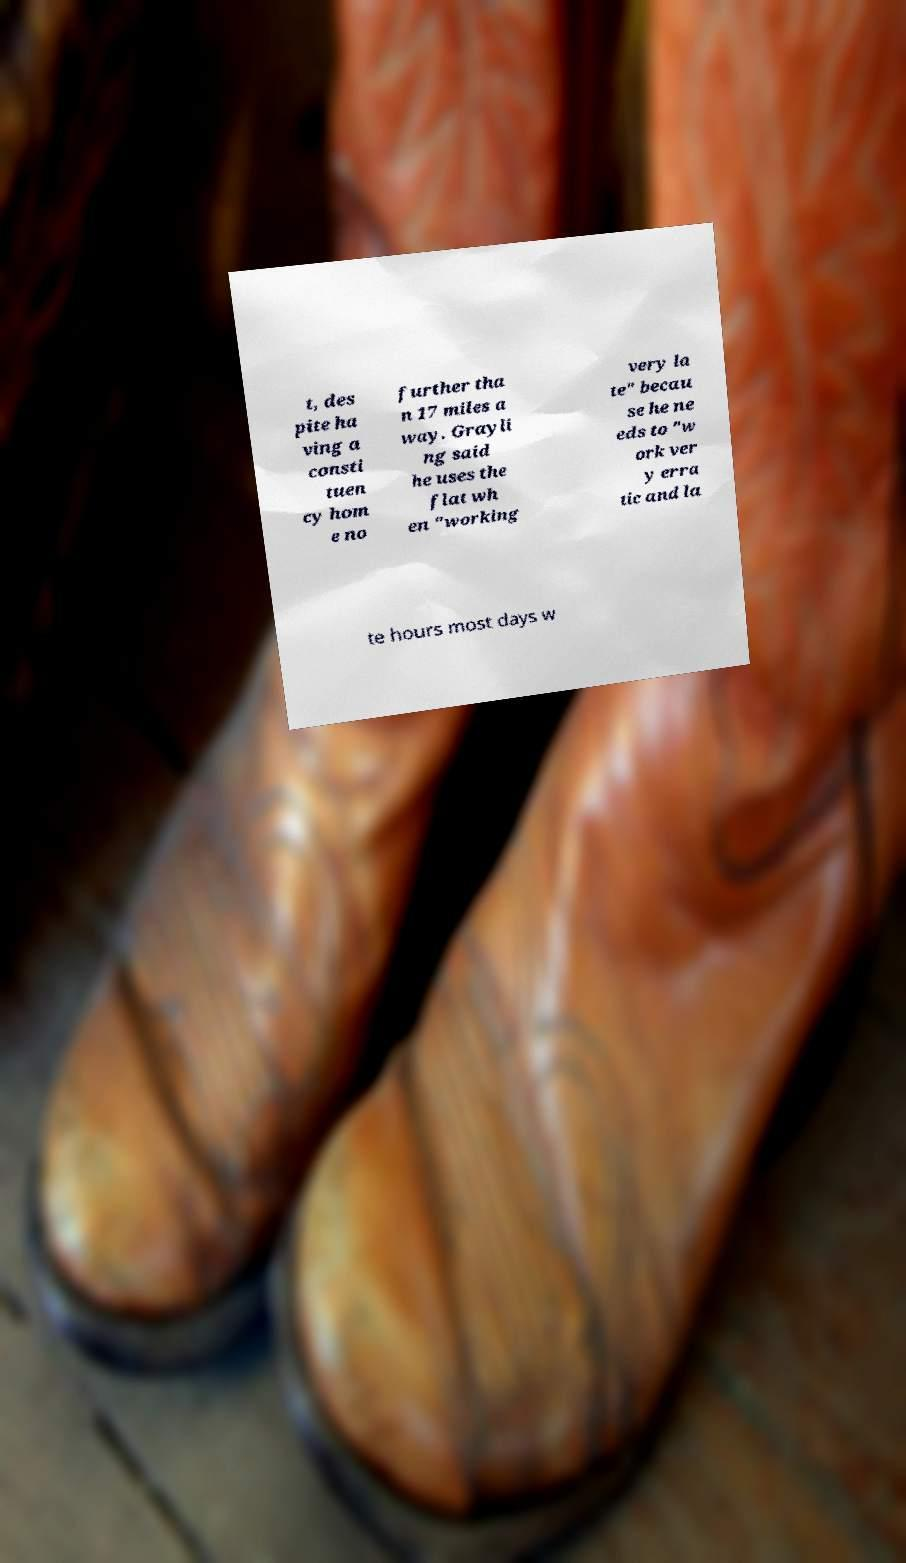Please read and relay the text visible in this image. What does it say? t, des pite ha ving a consti tuen cy hom e no further tha n 17 miles a way. Grayli ng said he uses the flat wh en "working very la te" becau se he ne eds to "w ork ver y erra tic and la te hours most days w 